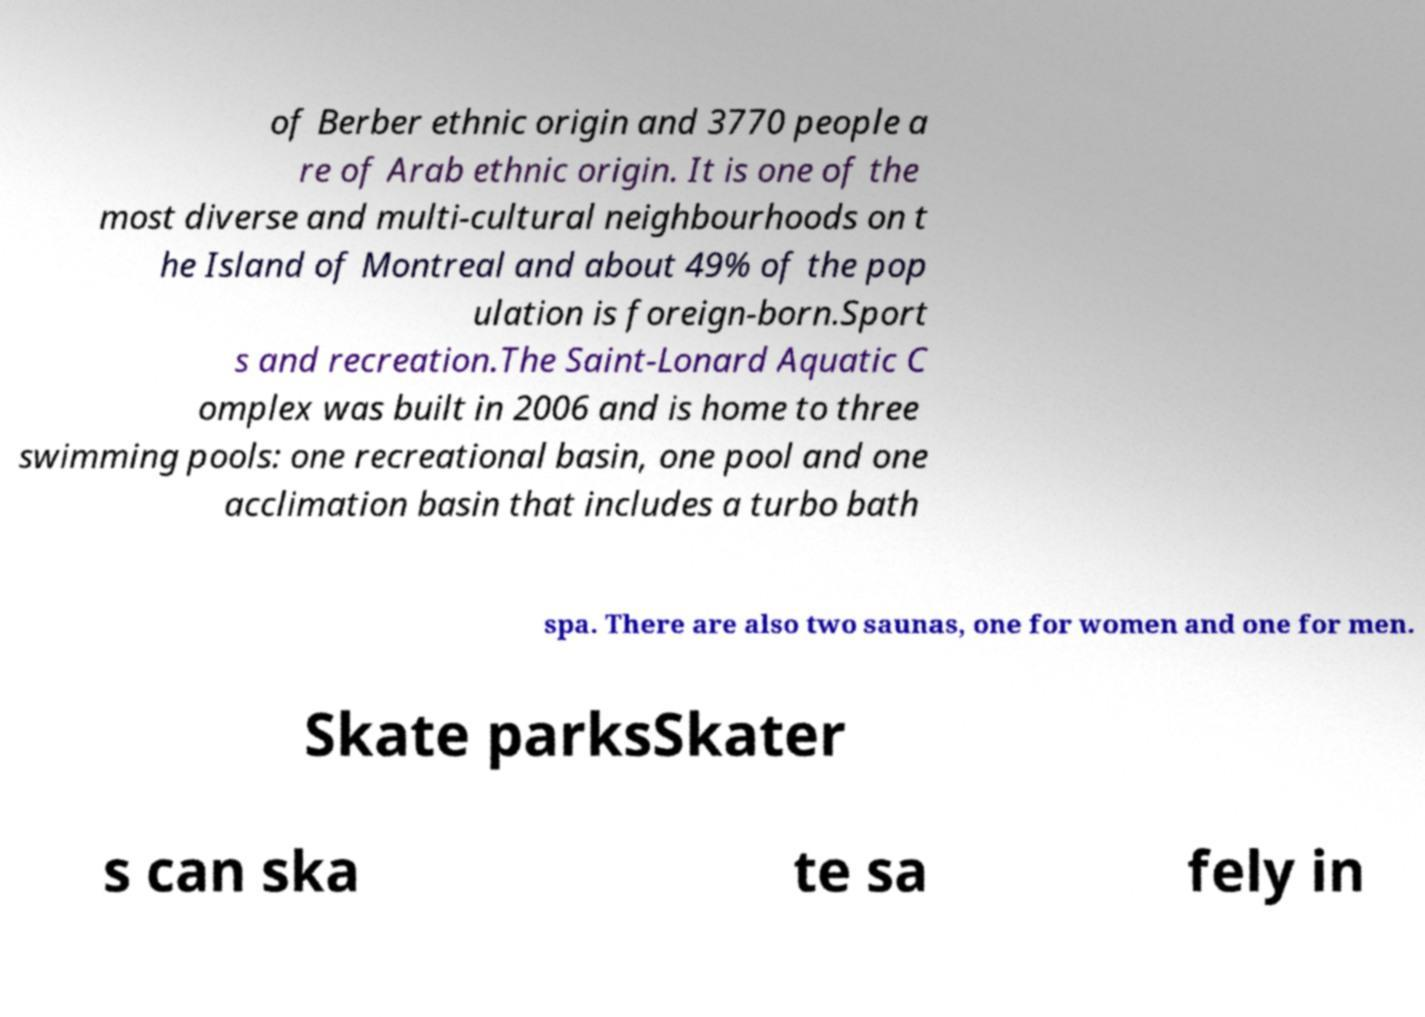What messages or text are displayed in this image? I need them in a readable, typed format. of Berber ethnic origin and 3770 people a re of Arab ethnic origin. It is one of the most diverse and multi-cultural neighbourhoods on t he Island of Montreal and about 49% of the pop ulation is foreign-born.Sport s and recreation.The Saint-Lonard Aquatic C omplex was built in 2006 and is home to three swimming pools: one recreational basin, one pool and one acclimation basin that includes a turbo bath spa. There are also two saunas, one for women and one for men. Skate parksSkater s can ska te sa fely in 